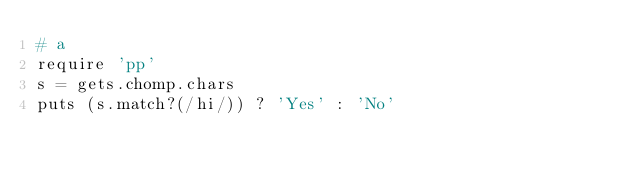Convert code to text. <code><loc_0><loc_0><loc_500><loc_500><_Ruby_># a
require 'pp'
s = gets.chomp.chars
puts (s.match?(/hi/)) ? 'Yes' : 'No'


</code> 